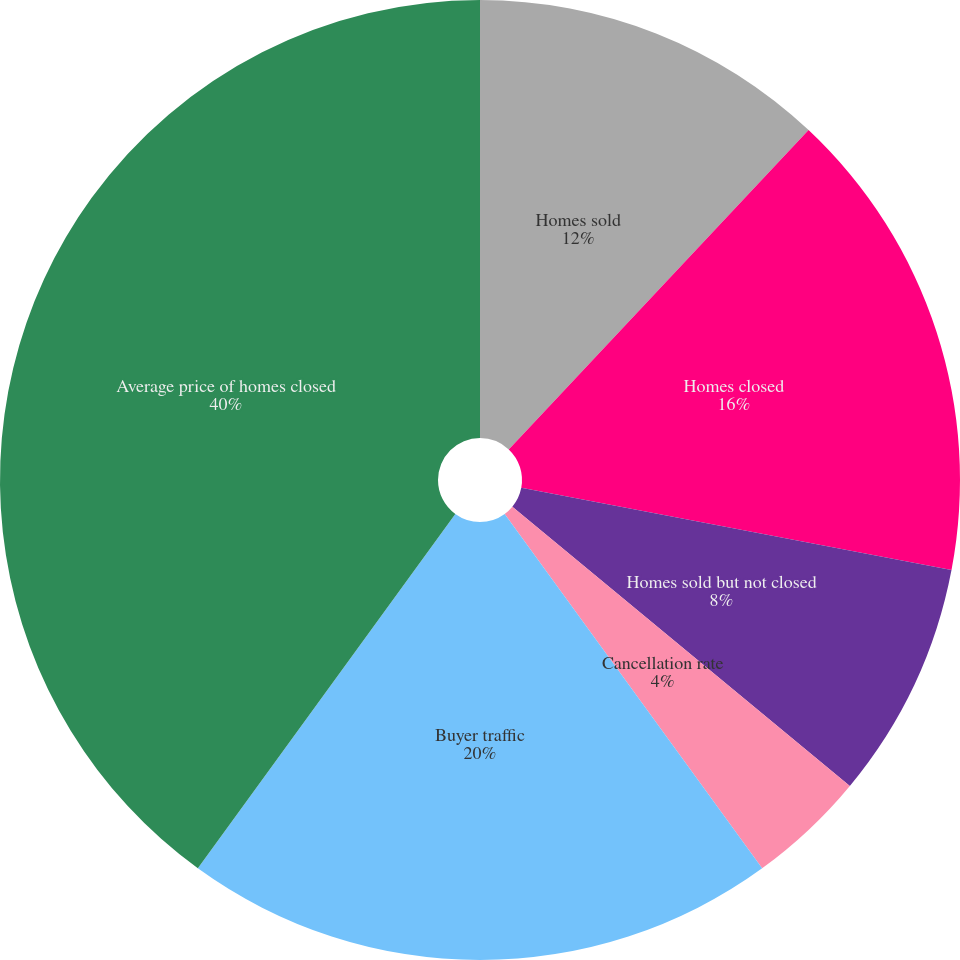Convert chart. <chart><loc_0><loc_0><loc_500><loc_500><pie_chart><fcel>Homes sold<fcel>Homes closed<fcel>Homes sold but not closed<fcel>Cancellation rate<fcel>Buyer traffic<fcel>Average price of homes closed<fcel>Single-family gross margin -<nl><fcel>12.0%<fcel>16.0%<fcel>8.0%<fcel>4.0%<fcel>20.0%<fcel>40.0%<fcel>0.0%<nl></chart> 